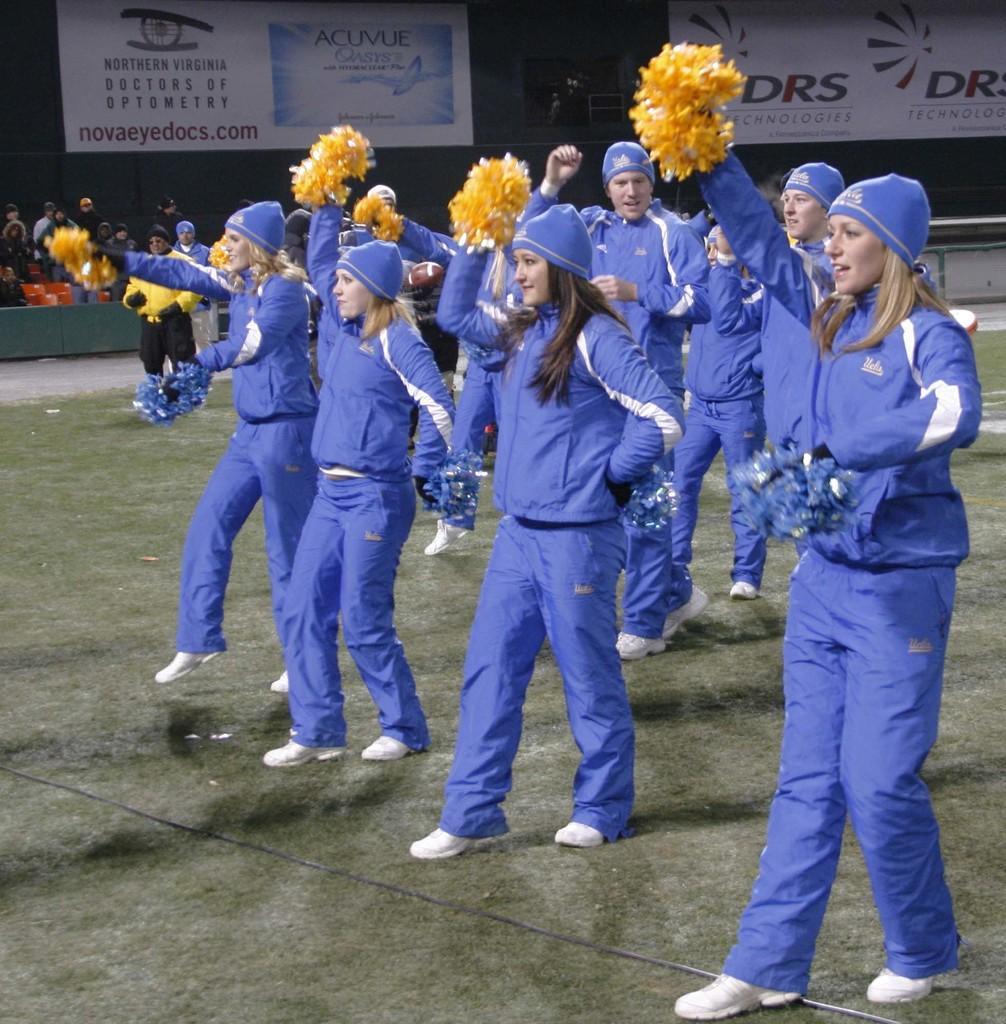Can you describe this image briefly? In the image there are a group of people dancing by holding some objects in their hands, behind them they are banners and other people. 